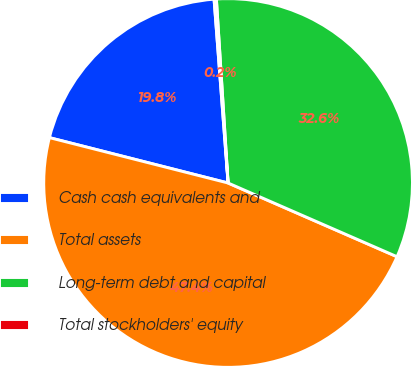Convert chart to OTSL. <chart><loc_0><loc_0><loc_500><loc_500><pie_chart><fcel>Cash cash equivalents and<fcel>Total assets<fcel>Long-term debt and capital<fcel>Total stockholders' equity<nl><fcel>19.83%<fcel>47.41%<fcel>32.56%<fcel>0.2%<nl></chart> 